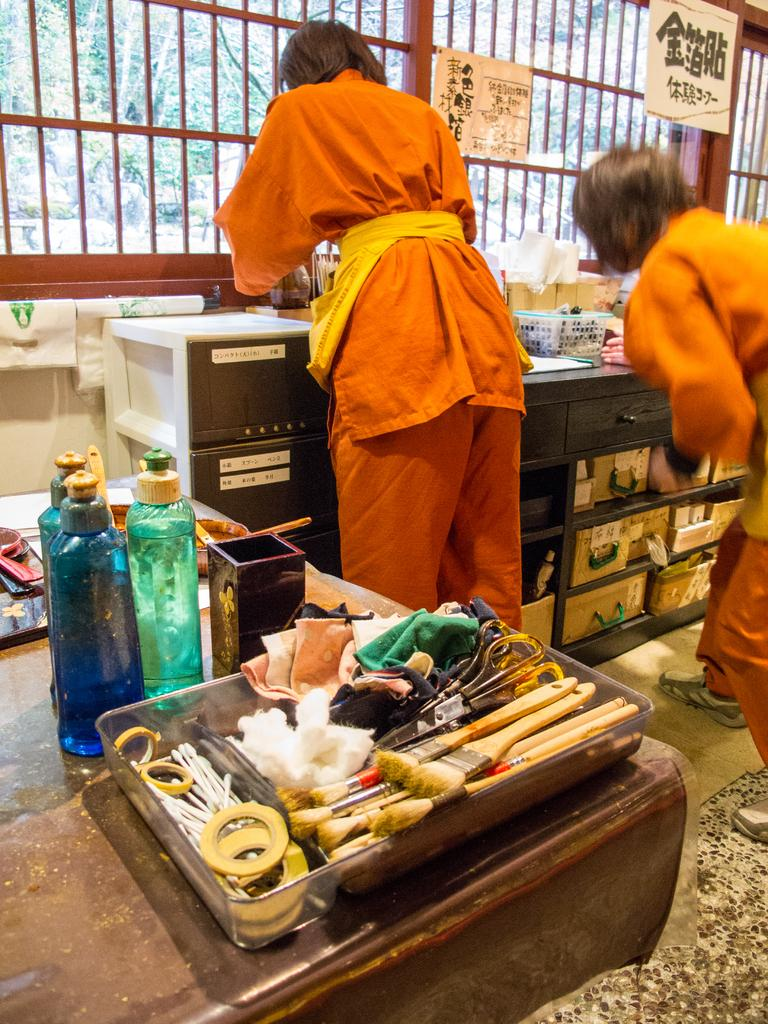What tools are visible in the image? There are brushes and a scissor in the image. What material is present in the image? There is cloth in the image. How many bottles are on the table in the image? There are three bottles on a table in the image. What are the two persons in the image doing? The two persons are standing and doing some work in the image. What can be seen in the background of the image? There is a railing and a tree in the background of the image. What type of flower is being used as a prop by the uncle in the image? There is no uncle or flower present in the image. How many bridges can be seen in the image? There are no bridges visible in the image. 